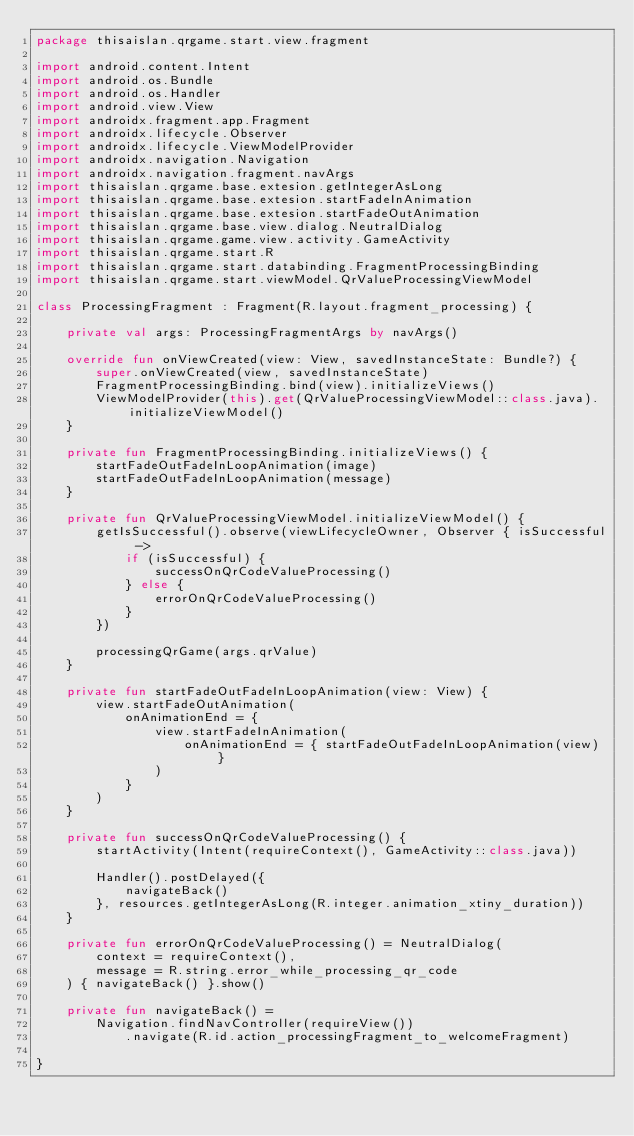Convert code to text. <code><loc_0><loc_0><loc_500><loc_500><_Kotlin_>package thisaislan.qrgame.start.view.fragment

import android.content.Intent
import android.os.Bundle
import android.os.Handler
import android.view.View
import androidx.fragment.app.Fragment
import androidx.lifecycle.Observer
import androidx.lifecycle.ViewModelProvider
import androidx.navigation.Navigation
import androidx.navigation.fragment.navArgs
import thisaislan.qrgame.base.extesion.getIntegerAsLong
import thisaislan.qrgame.base.extesion.startFadeInAnimation
import thisaislan.qrgame.base.extesion.startFadeOutAnimation
import thisaislan.qrgame.base.view.dialog.NeutralDialog
import thisaislan.qrgame.game.view.activity.GameActivity
import thisaislan.qrgame.start.R
import thisaislan.qrgame.start.databinding.FragmentProcessingBinding
import thisaislan.qrgame.start.viewModel.QrValueProcessingViewModel

class ProcessingFragment : Fragment(R.layout.fragment_processing) {

    private val args: ProcessingFragmentArgs by navArgs()

    override fun onViewCreated(view: View, savedInstanceState: Bundle?) {
        super.onViewCreated(view, savedInstanceState)
        FragmentProcessingBinding.bind(view).initializeViews()
        ViewModelProvider(this).get(QrValueProcessingViewModel::class.java).initializeViewModel()
    }

    private fun FragmentProcessingBinding.initializeViews() {
        startFadeOutFadeInLoopAnimation(image)
        startFadeOutFadeInLoopAnimation(message)
    }

    private fun QrValueProcessingViewModel.initializeViewModel() {
        getIsSuccessful().observe(viewLifecycleOwner, Observer { isSuccessful ->
            if (isSuccessful) {
                successOnQrCodeValueProcessing()
            } else {
                errorOnQrCodeValueProcessing()
            }
        })

        processingQrGame(args.qrValue)
    }

    private fun startFadeOutFadeInLoopAnimation(view: View) {
        view.startFadeOutAnimation(
            onAnimationEnd = {
                view.startFadeInAnimation(
                    onAnimationEnd = { startFadeOutFadeInLoopAnimation(view) }
                )
            }
        )
    }

    private fun successOnQrCodeValueProcessing() {
        startActivity(Intent(requireContext(), GameActivity::class.java))

        Handler().postDelayed({
            navigateBack()
        }, resources.getIntegerAsLong(R.integer.animation_xtiny_duration))
    }

    private fun errorOnQrCodeValueProcessing() = NeutralDialog(
        context = requireContext(),
        message = R.string.error_while_processing_qr_code
    ) { navigateBack() }.show()

    private fun navigateBack() =
        Navigation.findNavController(requireView())
            .navigate(R.id.action_processingFragment_to_welcomeFragment)

}</code> 